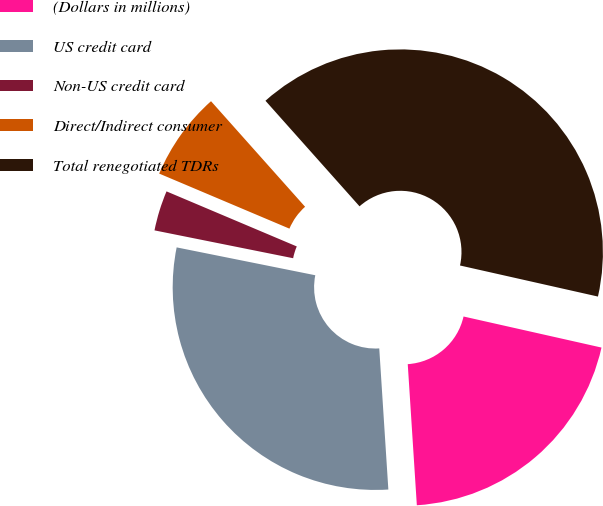Convert chart to OTSL. <chart><loc_0><loc_0><loc_500><loc_500><pie_chart><fcel>(Dollars in millions)<fcel>US credit card<fcel>Non-US credit card<fcel>Direct/Indirect consumer<fcel>Total renegotiated TDRs<nl><fcel>20.45%<fcel>29.18%<fcel>3.21%<fcel>7.05%<fcel>40.11%<nl></chart> 